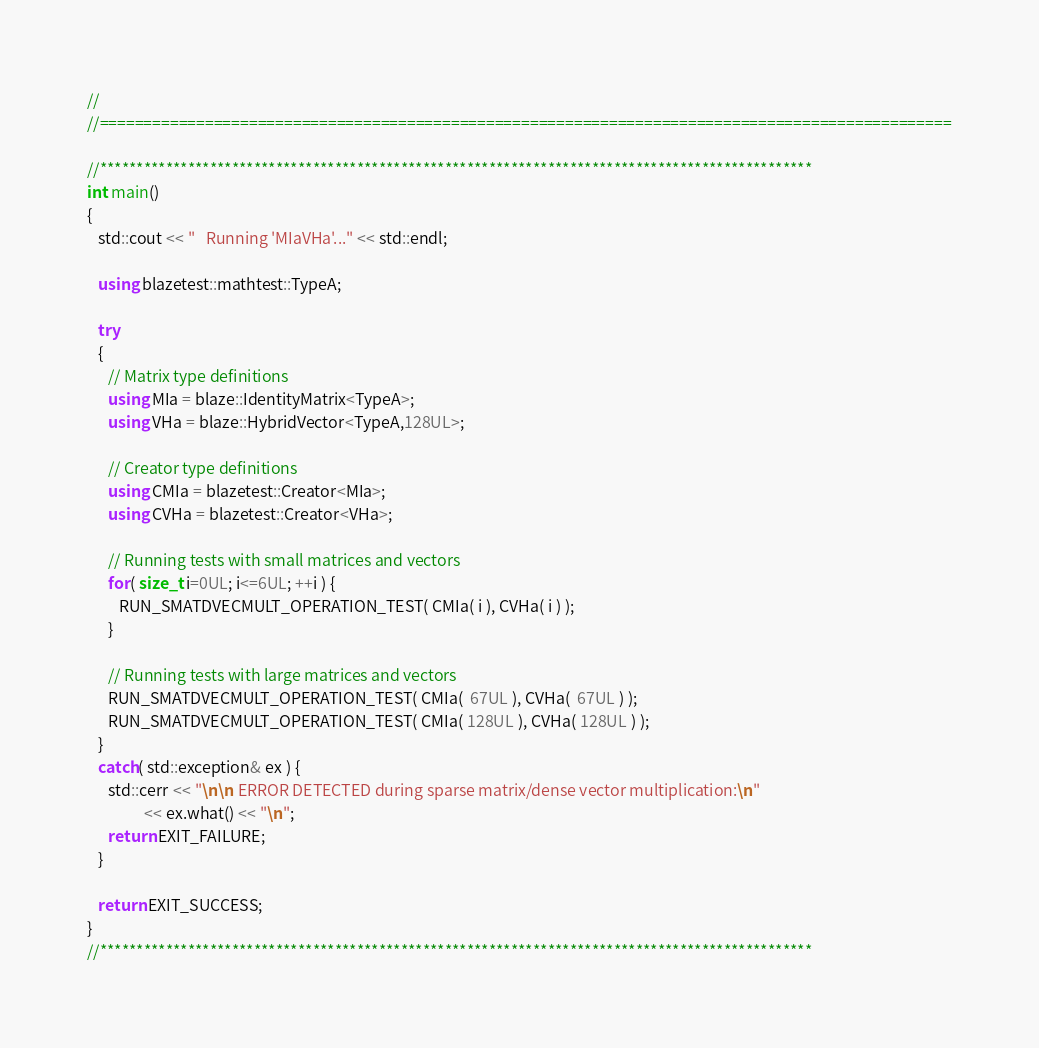<code> <loc_0><loc_0><loc_500><loc_500><_C++_>//
//=================================================================================================

//*************************************************************************************************
int main()
{
   std::cout << "   Running 'MIaVHa'..." << std::endl;

   using blazetest::mathtest::TypeA;

   try
   {
      // Matrix type definitions
      using MIa = blaze::IdentityMatrix<TypeA>;
      using VHa = blaze::HybridVector<TypeA,128UL>;

      // Creator type definitions
      using CMIa = blazetest::Creator<MIa>;
      using CVHa = blazetest::Creator<VHa>;

      // Running tests with small matrices and vectors
      for( size_t i=0UL; i<=6UL; ++i ) {
         RUN_SMATDVECMULT_OPERATION_TEST( CMIa( i ), CVHa( i ) );
      }

      // Running tests with large matrices and vectors
      RUN_SMATDVECMULT_OPERATION_TEST( CMIa(  67UL ), CVHa(  67UL ) );
      RUN_SMATDVECMULT_OPERATION_TEST( CMIa( 128UL ), CVHa( 128UL ) );
   }
   catch( std::exception& ex ) {
      std::cerr << "\n\n ERROR DETECTED during sparse matrix/dense vector multiplication:\n"
                << ex.what() << "\n";
      return EXIT_FAILURE;
   }

   return EXIT_SUCCESS;
}
//*************************************************************************************************
</code> 